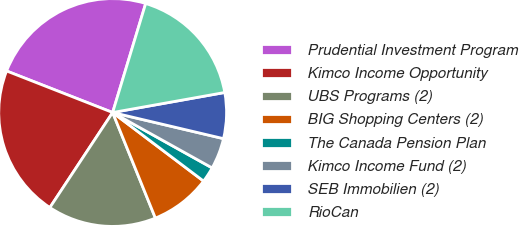<chart> <loc_0><loc_0><loc_500><loc_500><pie_chart><fcel>Prudential Investment Program<fcel>Kimco Income Opportunity<fcel>UBS Programs (2)<fcel>BIG Shopping Centers (2)<fcel>The Canada Pension Plan<fcel>Kimco Income Fund (2)<fcel>SEB Immobilien (2)<fcel>RioCan<nl><fcel>23.74%<fcel>21.65%<fcel>15.41%<fcel>8.59%<fcel>2.2%<fcel>4.4%<fcel>6.5%<fcel>17.5%<nl></chart> 